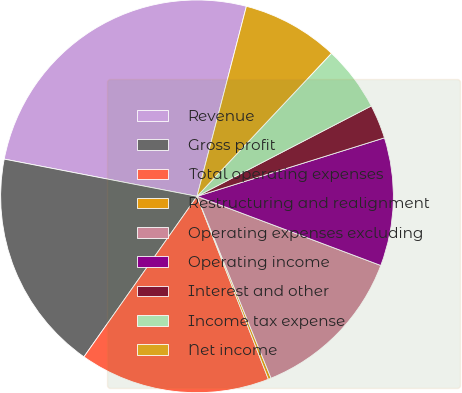Convert chart. <chart><loc_0><loc_0><loc_500><loc_500><pie_chart><fcel>Revenue<fcel>Gross profit<fcel>Total operating expenses<fcel>Restructuring and realignment<fcel>Operating expenses excluding<fcel>Operating income<fcel>Interest and other<fcel>Income tax expense<fcel>Net income<nl><fcel>26.01%<fcel>18.27%<fcel>15.69%<fcel>0.23%<fcel>13.12%<fcel>10.54%<fcel>2.8%<fcel>5.38%<fcel>7.96%<nl></chart> 